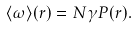Convert formula to latex. <formula><loc_0><loc_0><loc_500><loc_500>\langle \omega \rangle ( { r } ) = N \gamma P ( { r } ) .</formula> 